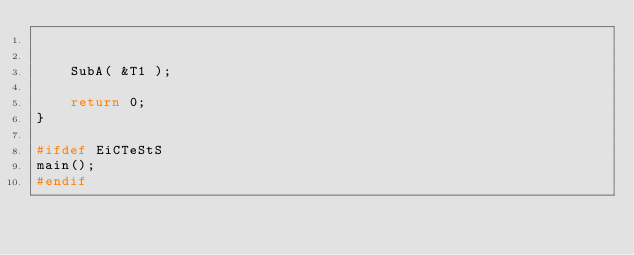Convert code to text. <code><loc_0><loc_0><loc_500><loc_500><_C_>

    SubA( &T1 );
    
    return 0;
}

#ifdef EiCTeStS
main();
#endif







</code> 